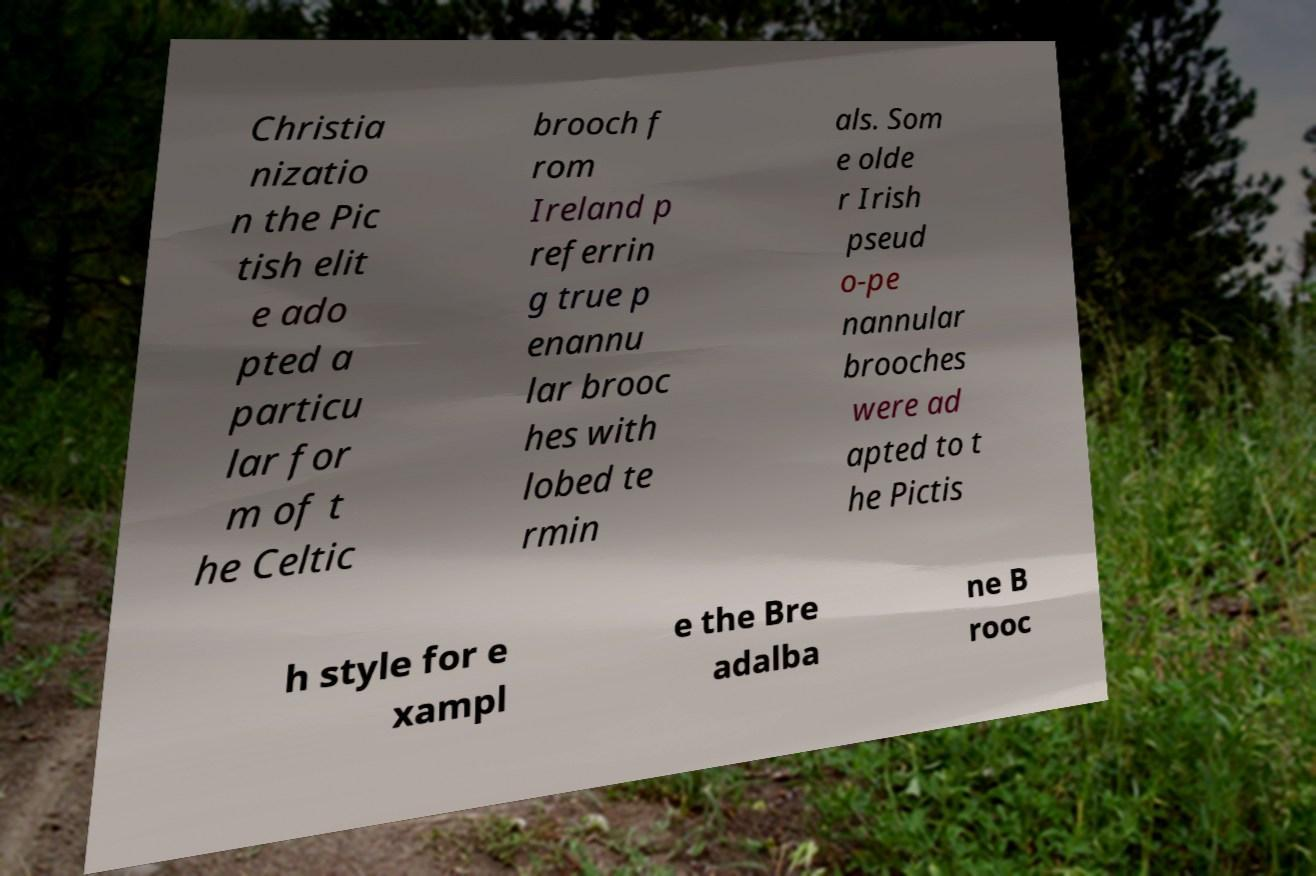What messages or text are displayed in this image? I need them in a readable, typed format. Christia nizatio n the Pic tish elit e ado pted a particu lar for m of t he Celtic brooch f rom Ireland p referrin g true p enannu lar brooc hes with lobed te rmin als. Som e olde r Irish pseud o-pe nannular brooches were ad apted to t he Pictis h style for e xampl e the Bre adalba ne B rooc 